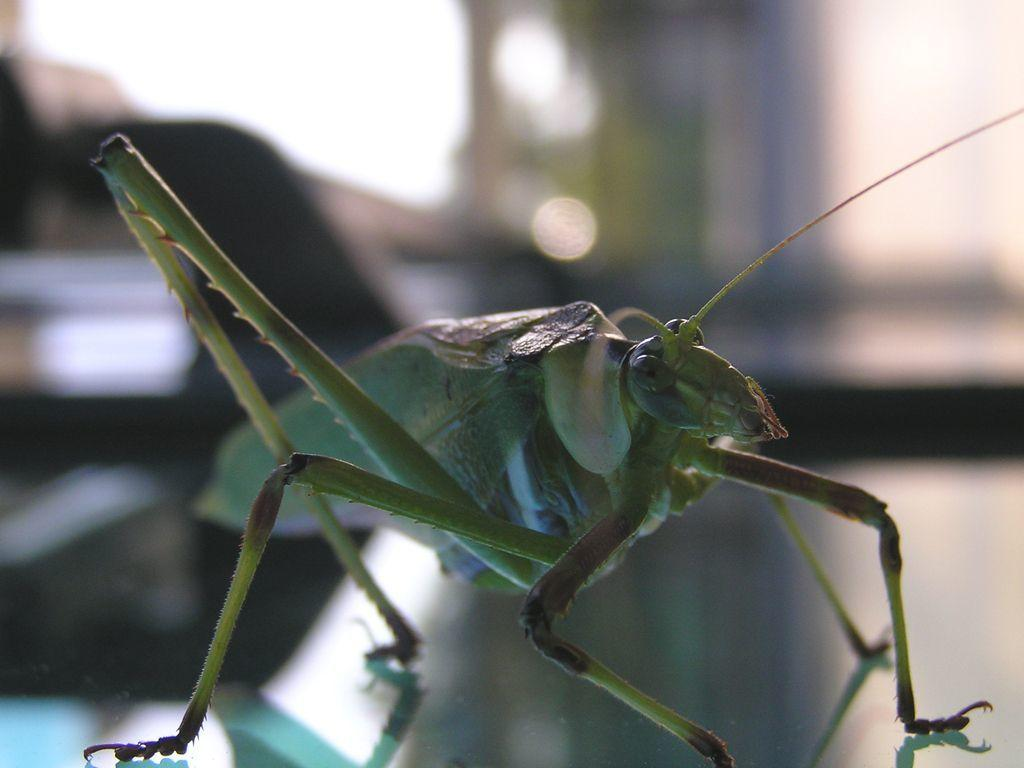What type of creature can be seen in the image? There is an insect in the image. Can you describe the background of the image? The background of the image is blurry. What type of station is the insect waiting at in the image? There is no station present in the image, as it features an insect and a blurry background. 